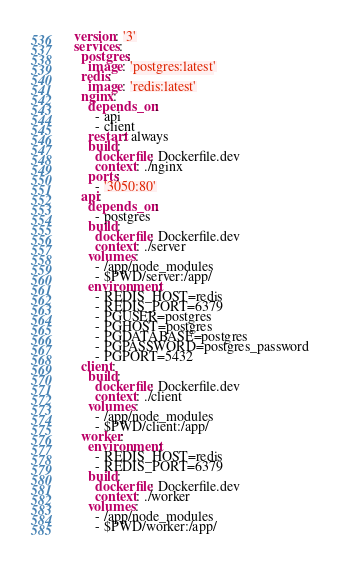Convert code to text. <code><loc_0><loc_0><loc_500><loc_500><_YAML_>version: '3'
services:
  postgres:
    image: 'postgres:latest'
  redis:
    image: 'redis:latest'
  nginx:
    depends_on:
      - api
      - client
    restart: always
    build:
      dockerfile: Dockerfile.dev
      context: ./nginx
    ports:
      - '3050:80'
  api:
    depends_on:
      - postgres
    build:
      dockerfile: Dockerfile.dev
      context: ./server
    volumes:
      - /app/node_modules
      - $PWD/server:/app/
    environment:
      - REDIS_HOST=redis
      - REDIS_PORT=6379
      - PGUSER=postgres
      - PGHOST=postgres
      - PGDATABASE=postgres
      - PGPASSWORD=postgres_password
      - PGPORT=5432
  client:
    build:
      dockerfile: Dockerfile.dev
      context: ./client
    volumes:
      - /app/node_modules
      - $PWD/client:/app/
  worker:
    environment:
      - REDIS_HOST=redis
      - REDIS_PORT=6379
    build:
      dockerfile: Dockerfile.dev
      context: ./worker
    volumes:
      - /app/node_modules
      - $PWD/worker:/app/
</code> 